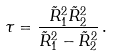Convert formula to latex. <formula><loc_0><loc_0><loc_500><loc_500>\tau = \frac { \tilde { R } _ { 1 } ^ { 2 } \tilde { R } _ { 2 } ^ { 2 } } { \tilde { R } _ { 1 } ^ { 2 } - \tilde { R } _ { 2 } ^ { 2 } } \, .</formula> 